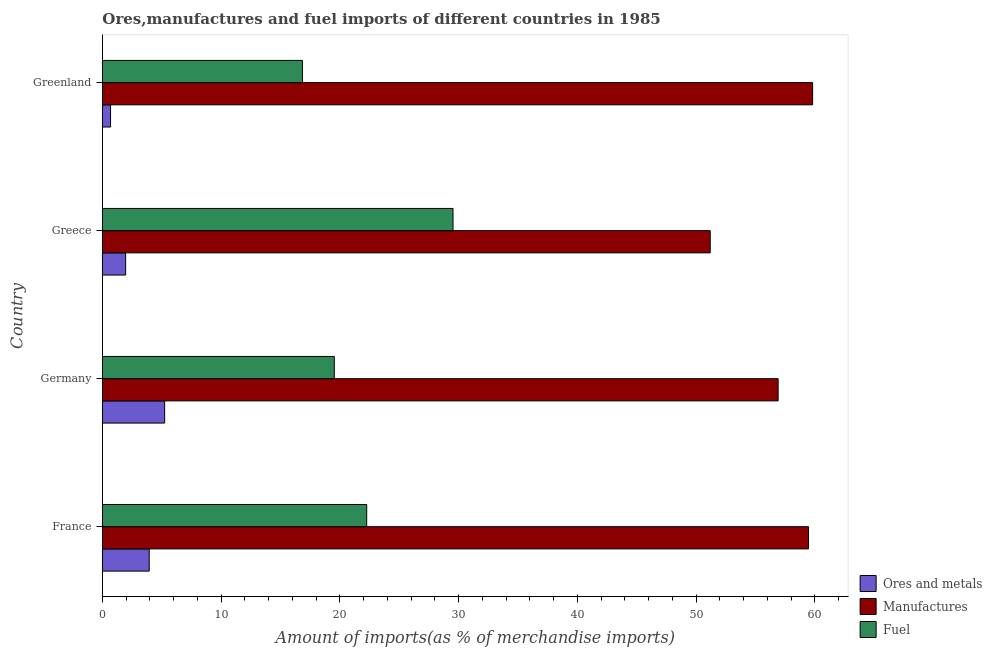How many groups of bars are there?
Give a very brief answer. 4. Are the number of bars per tick equal to the number of legend labels?
Offer a very short reply. Yes. In how many cases, is the number of bars for a given country not equal to the number of legend labels?
Provide a succinct answer. 0. What is the percentage of manufactures imports in Greenland?
Make the answer very short. 59.81. Across all countries, what is the maximum percentage of fuel imports?
Keep it short and to the point. 29.53. Across all countries, what is the minimum percentage of fuel imports?
Offer a terse response. 16.84. In which country was the percentage of ores and metals imports maximum?
Offer a very short reply. Germany. In which country was the percentage of fuel imports minimum?
Provide a succinct answer. Greenland. What is the total percentage of manufactures imports in the graph?
Ensure brevity in your answer.  227.39. What is the difference between the percentage of ores and metals imports in Germany and that in Greece?
Your answer should be compact. 3.28. What is the difference between the percentage of fuel imports in Greece and the percentage of ores and metals imports in Greenland?
Ensure brevity in your answer.  28.84. What is the average percentage of manufactures imports per country?
Give a very brief answer. 56.85. What is the difference between the percentage of ores and metals imports and percentage of fuel imports in Greece?
Offer a very short reply. -27.57. What is the ratio of the percentage of ores and metals imports in Greece to that in Greenland?
Provide a succinct answer. 2.86. What is the difference between the highest and the second highest percentage of ores and metals imports?
Provide a succinct answer. 1.3. What is the difference between the highest and the lowest percentage of fuel imports?
Keep it short and to the point. 12.68. In how many countries, is the percentage of fuel imports greater than the average percentage of fuel imports taken over all countries?
Offer a very short reply. 2. What does the 2nd bar from the top in Greenland represents?
Offer a very short reply. Manufactures. What does the 1st bar from the bottom in Greece represents?
Offer a terse response. Ores and metals. How many countries are there in the graph?
Offer a terse response. 4. What is the difference between two consecutive major ticks on the X-axis?
Give a very brief answer. 10. Are the values on the major ticks of X-axis written in scientific E-notation?
Give a very brief answer. No. Where does the legend appear in the graph?
Provide a succinct answer. Bottom right. How many legend labels are there?
Your response must be concise. 3. How are the legend labels stacked?
Offer a very short reply. Vertical. What is the title of the graph?
Provide a short and direct response. Ores,manufactures and fuel imports of different countries in 1985. What is the label or title of the X-axis?
Provide a succinct answer. Amount of imports(as % of merchandise imports). What is the Amount of imports(as % of merchandise imports) of Ores and metals in France?
Keep it short and to the point. 3.94. What is the Amount of imports(as % of merchandise imports) in Manufactures in France?
Your answer should be very brief. 59.47. What is the Amount of imports(as % of merchandise imports) in Fuel in France?
Offer a terse response. 22.26. What is the Amount of imports(as % of merchandise imports) of Ores and metals in Germany?
Provide a short and direct response. 5.24. What is the Amount of imports(as % of merchandise imports) of Manufactures in Germany?
Ensure brevity in your answer.  56.91. What is the Amount of imports(as % of merchandise imports) of Fuel in Germany?
Provide a succinct answer. 19.53. What is the Amount of imports(as % of merchandise imports) in Ores and metals in Greece?
Keep it short and to the point. 1.95. What is the Amount of imports(as % of merchandise imports) in Manufactures in Greece?
Your answer should be compact. 51.19. What is the Amount of imports(as % of merchandise imports) of Fuel in Greece?
Your answer should be very brief. 29.53. What is the Amount of imports(as % of merchandise imports) of Ores and metals in Greenland?
Keep it short and to the point. 0.68. What is the Amount of imports(as % of merchandise imports) in Manufactures in Greenland?
Provide a succinct answer. 59.81. What is the Amount of imports(as % of merchandise imports) of Fuel in Greenland?
Provide a short and direct response. 16.84. Across all countries, what is the maximum Amount of imports(as % of merchandise imports) of Ores and metals?
Your answer should be very brief. 5.24. Across all countries, what is the maximum Amount of imports(as % of merchandise imports) of Manufactures?
Make the answer very short. 59.81. Across all countries, what is the maximum Amount of imports(as % of merchandise imports) in Fuel?
Your answer should be compact. 29.53. Across all countries, what is the minimum Amount of imports(as % of merchandise imports) of Ores and metals?
Ensure brevity in your answer.  0.68. Across all countries, what is the minimum Amount of imports(as % of merchandise imports) of Manufactures?
Provide a short and direct response. 51.19. Across all countries, what is the minimum Amount of imports(as % of merchandise imports) of Fuel?
Give a very brief answer. 16.84. What is the total Amount of imports(as % of merchandise imports) in Ores and metals in the graph?
Provide a short and direct response. 11.81. What is the total Amount of imports(as % of merchandise imports) of Manufactures in the graph?
Provide a short and direct response. 227.39. What is the total Amount of imports(as % of merchandise imports) in Fuel in the graph?
Your answer should be compact. 88.15. What is the difference between the Amount of imports(as % of merchandise imports) of Ores and metals in France and that in Germany?
Provide a succinct answer. -1.3. What is the difference between the Amount of imports(as % of merchandise imports) in Manufactures in France and that in Germany?
Your answer should be very brief. 2.56. What is the difference between the Amount of imports(as % of merchandise imports) in Fuel in France and that in Germany?
Keep it short and to the point. 2.73. What is the difference between the Amount of imports(as % of merchandise imports) in Ores and metals in France and that in Greece?
Offer a very short reply. 1.99. What is the difference between the Amount of imports(as % of merchandise imports) of Manufactures in France and that in Greece?
Make the answer very short. 8.28. What is the difference between the Amount of imports(as % of merchandise imports) in Fuel in France and that in Greece?
Give a very brief answer. -7.27. What is the difference between the Amount of imports(as % of merchandise imports) of Ores and metals in France and that in Greenland?
Give a very brief answer. 3.26. What is the difference between the Amount of imports(as % of merchandise imports) of Manufactures in France and that in Greenland?
Make the answer very short. -0.34. What is the difference between the Amount of imports(as % of merchandise imports) of Fuel in France and that in Greenland?
Give a very brief answer. 5.41. What is the difference between the Amount of imports(as % of merchandise imports) in Ores and metals in Germany and that in Greece?
Your response must be concise. 3.28. What is the difference between the Amount of imports(as % of merchandise imports) of Manufactures in Germany and that in Greece?
Make the answer very short. 5.72. What is the difference between the Amount of imports(as % of merchandise imports) in Fuel in Germany and that in Greece?
Provide a short and direct response. -10. What is the difference between the Amount of imports(as % of merchandise imports) of Ores and metals in Germany and that in Greenland?
Offer a terse response. 4.56. What is the difference between the Amount of imports(as % of merchandise imports) of Manufactures in Germany and that in Greenland?
Give a very brief answer. -2.9. What is the difference between the Amount of imports(as % of merchandise imports) of Fuel in Germany and that in Greenland?
Provide a succinct answer. 2.69. What is the difference between the Amount of imports(as % of merchandise imports) in Ores and metals in Greece and that in Greenland?
Provide a short and direct response. 1.27. What is the difference between the Amount of imports(as % of merchandise imports) of Manufactures in Greece and that in Greenland?
Your answer should be very brief. -8.62. What is the difference between the Amount of imports(as % of merchandise imports) of Fuel in Greece and that in Greenland?
Offer a terse response. 12.68. What is the difference between the Amount of imports(as % of merchandise imports) in Ores and metals in France and the Amount of imports(as % of merchandise imports) in Manufactures in Germany?
Provide a succinct answer. -52.97. What is the difference between the Amount of imports(as % of merchandise imports) in Ores and metals in France and the Amount of imports(as % of merchandise imports) in Fuel in Germany?
Give a very brief answer. -15.59. What is the difference between the Amount of imports(as % of merchandise imports) of Manufactures in France and the Amount of imports(as % of merchandise imports) of Fuel in Germany?
Make the answer very short. 39.94. What is the difference between the Amount of imports(as % of merchandise imports) in Ores and metals in France and the Amount of imports(as % of merchandise imports) in Manufactures in Greece?
Give a very brief answer. -47.25. What is the difference between the Amount of imports(as % of merchandise imports) of Ores and metals in France and the Amount of imports(as % of merchandise imports) of Fuel in Greece?
Give a very brief answer. -25.59. What is the difference between the Amount of imports(as % of merchandise imports) in Manufactures in France and the Amount of imports(as % of merchandise imports) in Fuel in Greece?
Your answer should be very brief. 29.95. What is the difference between the Amount of imports(as % of merchandise imports) in Ores and metals in France and the Amount of imports(as % of merchandise imports) in Manufactures in Greenland?
Offer a very short reply. -55.87. What is the difference between the Amount of imports(as % of merchandise imports) in Ores and metals in France and the Amount of imports(as % of merchandise imports) in Fuel in Greenland?
Provide a succinct answer. -12.9. What is the difference between the Amount of imports(as % of merchandise imports) of Manufactures in France and the Amount of imports(as % of merchandise imports) of Fuel in Greenland?
Keep it short and to the point. 42.63. What is the difference between the Amount of imports(as % of merchandise imports) in Ores and metals in Germany and the Amount of imports(as % of merchandise imports) in Manufactures in Greece?
Your answer should be very brief. -45.95. What is the difference between the Amount of imports(as % of merchandise imports) in Ores and metals in Germany and the Amount of imports(as % of merchandise imports) in Fuel in Greece?
Your answer should be very brief. -24.29. What is the difference between the Amount of imports(as % of merchandise imports) in Manufactures in Germany and the Amount of imports(as % of merchandise imports) in Fuel in Greece?
Provide a short and direct response. 27.38. What is the difference between the Amount of imports(as % of merchandise imports) in Ores and metals in Germany and the Amount of imports(as % of merchandise imports) in Manufactures in Greenland?
Offer a very short reply. -54.58. What is the difference between the Amount of imports(as % of merchandise imports) in Ores and metals in Germany and the Amount of imports(as % of merchandise imports) in Fuel in Greenland?
Your response must be concise. -11.6. What is the difference between the Amount of imports(as % of merchandise imports) in Manufactures in Germany and the Amount of imports(as % of merchandise imports) in Fuel in Greenland?
Give a very brief answer. 40.07. What is the difference between the Amount of imports(as % of merchandise imports) in Ores and metals in Greece and the Amount of imports(as % of merchandise imports) in Manufactures in Greenland?
Provide a succinct answer. -57.86. What is the difference between the Amount of imports(as % of merchandise imports) in Ores and metals in Greece and the Amount of imports(as % of merchandise imports) in Fuel in Greenland?
Keep it short and to the point. -14.89. What is the difference between the Amount of imports(as % of merchandise imports) of Manufactures in Greece and the Amount of imports(as % of merchandise imports) of Fuel in Greenland?
Make the answer very short. 34.35. What is the average Amount of imports(as % of merchandise imports) of Ores and metals per country?
Provide a short and direct response. 2.95. What is the average Amount of imports(as % of merchandise imports) of Manufactures per country?
Your answer should be compact. 56.85. What is the average Amount of imports(as % of merchandise imports) of Fuel per country?
Ensure brevity in your answer.  22.04. What is the difference between the Amount of imports(as % of merchandise imports) in Ores and metals and Amount of imports(as % of merchandise imports) in Manufactures in France?
Offer a terse response. -55.53. What is the difference between the Amount of imports(as % of merchandise imports) of Ores and metals and Amount of imports(as % of merchandise imports) of Fuel in France?
Offer a terse response. -18.32. What is the difference between the Amount of imports(as % of merchandise imports) in Manufactures and Amount of imports(as % of merchandise imports) in Fuel in France?
Make the answer very short. 37.22. What is the difference between the Amount of imports(as % of merchandise imports) of Ores and metals and Amount of imports(as % of merchandise imports) of Manufactures in Germany?
Your response must be concise. -51.67. What is the difference between the Amount of imports(as % of merchandise imports) in Ores and metals and Amount of imports(as % of merchandise imports) in Fuel in Germany?
Give a very brief answer. -14.29. What is the difference between the Amount of imports(as % of merchandise imports) in Manufactures and Amount of imports(as % of merchandise imports) in Fuel in Germany?
Your answer should be very brief. 37.38. What is the difference between the Amount of imports(as % of merchandise imports) in Ores and metals and Amount of imports(as % of merchandise imports) in Manufactures in Greece?
Provide a succinct answer. -49.24. What is the difference between the Amount of imports(as % of merchandise imports) of Ores and metals and Amount of imports(as % of merchandise imports) of Fuel in Greece?
Keep it short and to the point. -27.57. What is the difference between the Amount of imports(as % of merchandise imports) in Manufactures and Amount of imports(as % of merchandise imports) in Fuel in Greece?
Offer a terse response. 21.66. What is the difference between the Amount of imports(as % of merchandise imports) of Ores and metals and Amount of imports(as % of merchandise imports) of Manufactures in Greenland?
Provide a short and direct response. -59.13. What is the difference between the Amount of imports(as % of merchandise imports) in Ores and metals and Amount of imports(as % of merchandise imports) in Fuel in Greenland?
Offer a very short reply. -16.16. What is the difference between the Amount of imports(as % of merchandise imports) of Manufactures and Amount of imports(as % of merchandise imports) of Fuel in Greenland?
Ensure brevity in your answer.  42.97. What is the ratio of the Amount of imports(as % of merchandise imports) of Ores and metals in France to that in Germany?
Keep it short and to the point. 0.75. What is the ratio of the Amount of imports(as % of merchandise imports) of Manufactures in France to that in Germany?
Your response must be concise. 1.04. What is the ratio of the Amount of imports(as % of merchandise imports) of Fuel in France to that in Germany?
Provide a short and direct response. 1.14. What is the ratio of the Amount of imports(as % of merchandise imports) of Ores and metals in France to that in Greece?
Offer a terse response. 2.02. What is the ratio of the Amount of imports(as % of merchandise imports) in Manufactures in France to that in Greece?
Keep it short and to the point. 1.16. What is the ratio of the Amount of imports(as % of merchandise imports) of Fuel in France to that in Greece?
Your response must be concise. 0.75. What is the ratio of the Amount of imports(as % of merchandise imports) in Ores and metals in France to that in Greenland?
Provide a succinct answer. 5.77. What is the ratio of the Amount of imports(as % of merchandise imports) of Manufactures in France to that in Greenland?
Ensure brevity in your answer.  0.99. What is the ratio of the Amount of imports(as % of merchandise imports) in Fuel in France to that in Greenland?
Provide a succinct answer. 1.32. What is the ratio of the Amount of imports(as % of merchandise imports) in Ores and metals in Germany to that in Greece?
Your answer should be compact. 2.68. What is the ratio of the Amount of imports(as % of merchandise imports) of Manufactures in Germany to that in Greece?
Ensure brevity in your answer.  1.11. What is the ratio of the Amount of imports(as % of merchandise imports) in Fuel in Germany to that in Greece?
Give a very brief answer. 0.66. What is the ratio of the Amount of imports(as % of merchandise imports) in Ores and metals in Germany to that in Greenland?
Keep it short and to the point. 7.67. What is the ratio of the Amount of imports(as % of merchandise imports) of Manufactures in Germany to that in Greenland?
Make the answer very short. 0.95. What is the ratio of the Amount of imports(as % of merchandise imports) in Fuel in Germany to that in Greenland?
Provide a succinct answer. 1.16. What is the ratio of the Amount of imports(as % of merchandise imports) in Ores and metals in Greece to that in Greenland?
Your answer should be compact. 2.86. What is the ratio of the Amount of imports(as % of merchandise imports) of Manufactures in Greece to that in Greenland?
Give a very brief answer. 0.86. What is the ratio of the Amount of imports(as % of merchandise imports) of Fuel in Greece to that in Greenland?
Give a very brief answer. 1.75. What is the difference between the highest and the second highest Amount of imports(as % of merchandise imports) of Ores and metals?
Offer a terse response. 1.3. What is the difference between the highest and the second highest Amount of imports(as % of merchandise imports) of Manufactures?
Give a very brief answer. 0.34. What is the difference between the highest and the second highest Amount of imports(as % of merchandise imports) of Fuel?
Your answer should be very brief. 7.27. What is the difference between the highest and the lowest Amount of imports(as % of merchandise imports) of Ores and metals?
Your response must be concise. 4.56. What is the difference between the highest and the lowest Amount of imports(as % of merchandise imports) of Manufactures?
Ensure brevity in your answer.  8.62. What is the difference between the highest and the lowest Amount of imports(as % of merchandise imports) in Fuel?
Your answer should be compact. 12.68. 